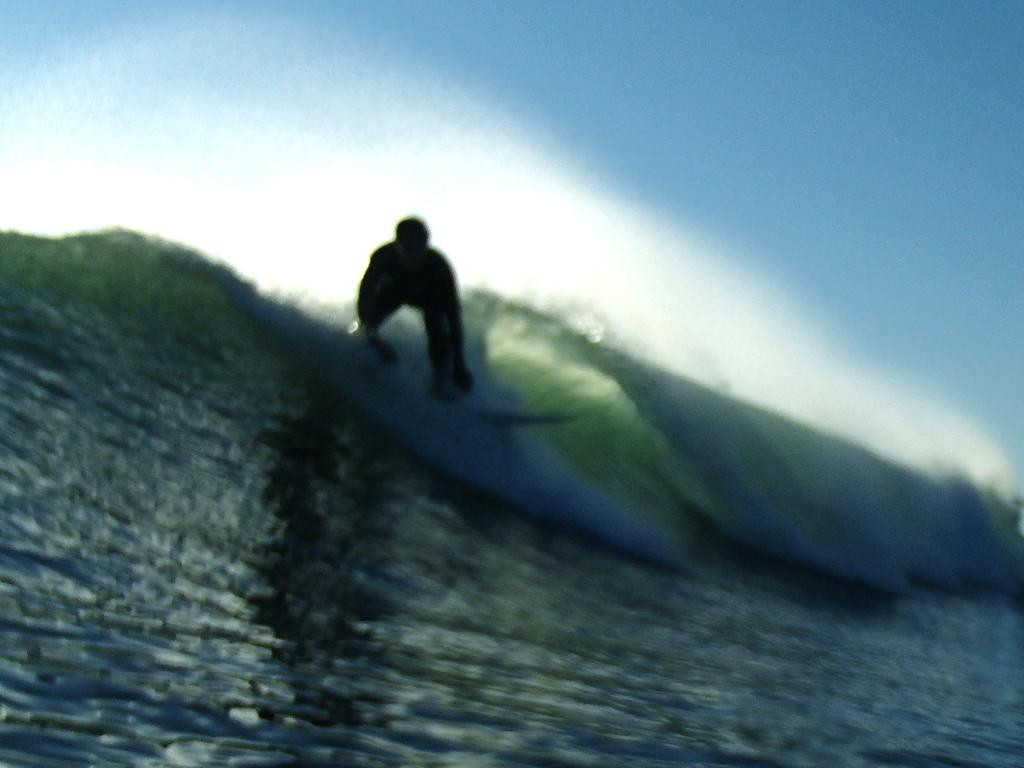What is the main subject of the picture? The main subject of the picture is a man. What is the man doing in the picture? The man is surfing in the water. What can be seen in the sky in the picture? There are clouds in the sky. What type of mice can be seen transporting a measuring tape in the image? There are no mice or measuring tape present in the image; it features a man surfing in the water with clouds in the sky. 